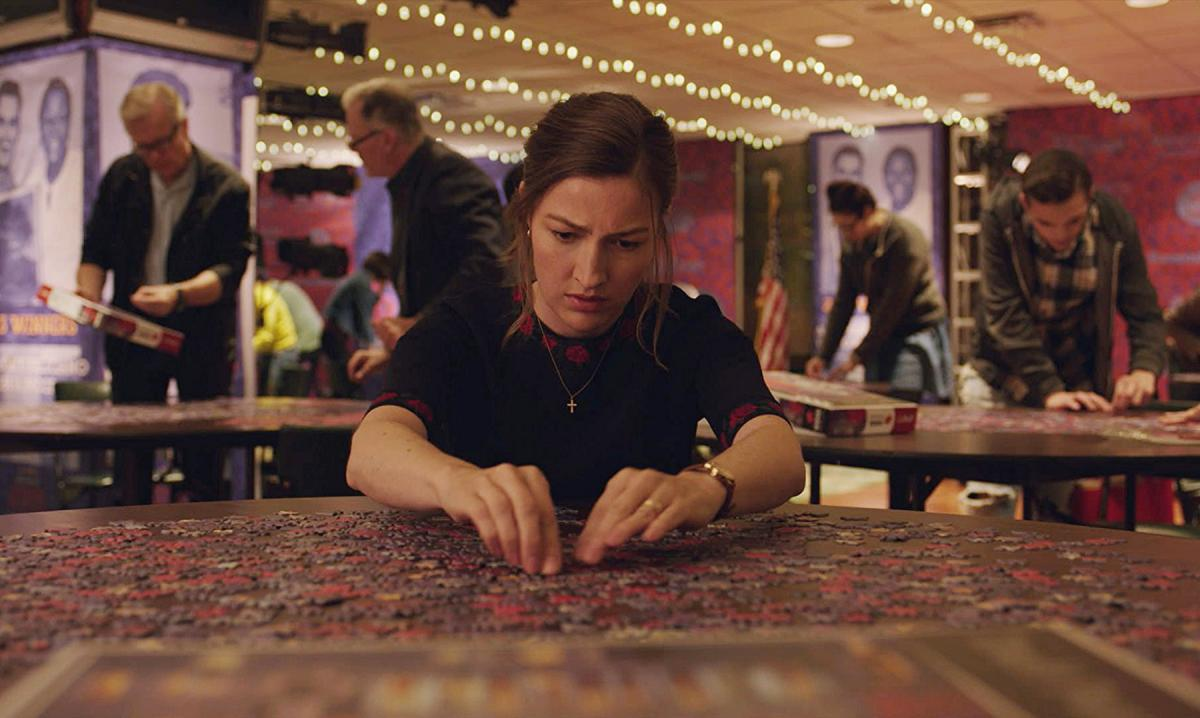What does the setting tell us about this activity? The setting, with its casual arrangement of tables and communal layout, surrounded by dim lighting and festive lights, indicates a social or community event focused on puzzle assembly. It suggests that this activity is not just a solitary pursuit but also a social one, where individuals gather to share in the joy and challenge of puzzle-solving. 